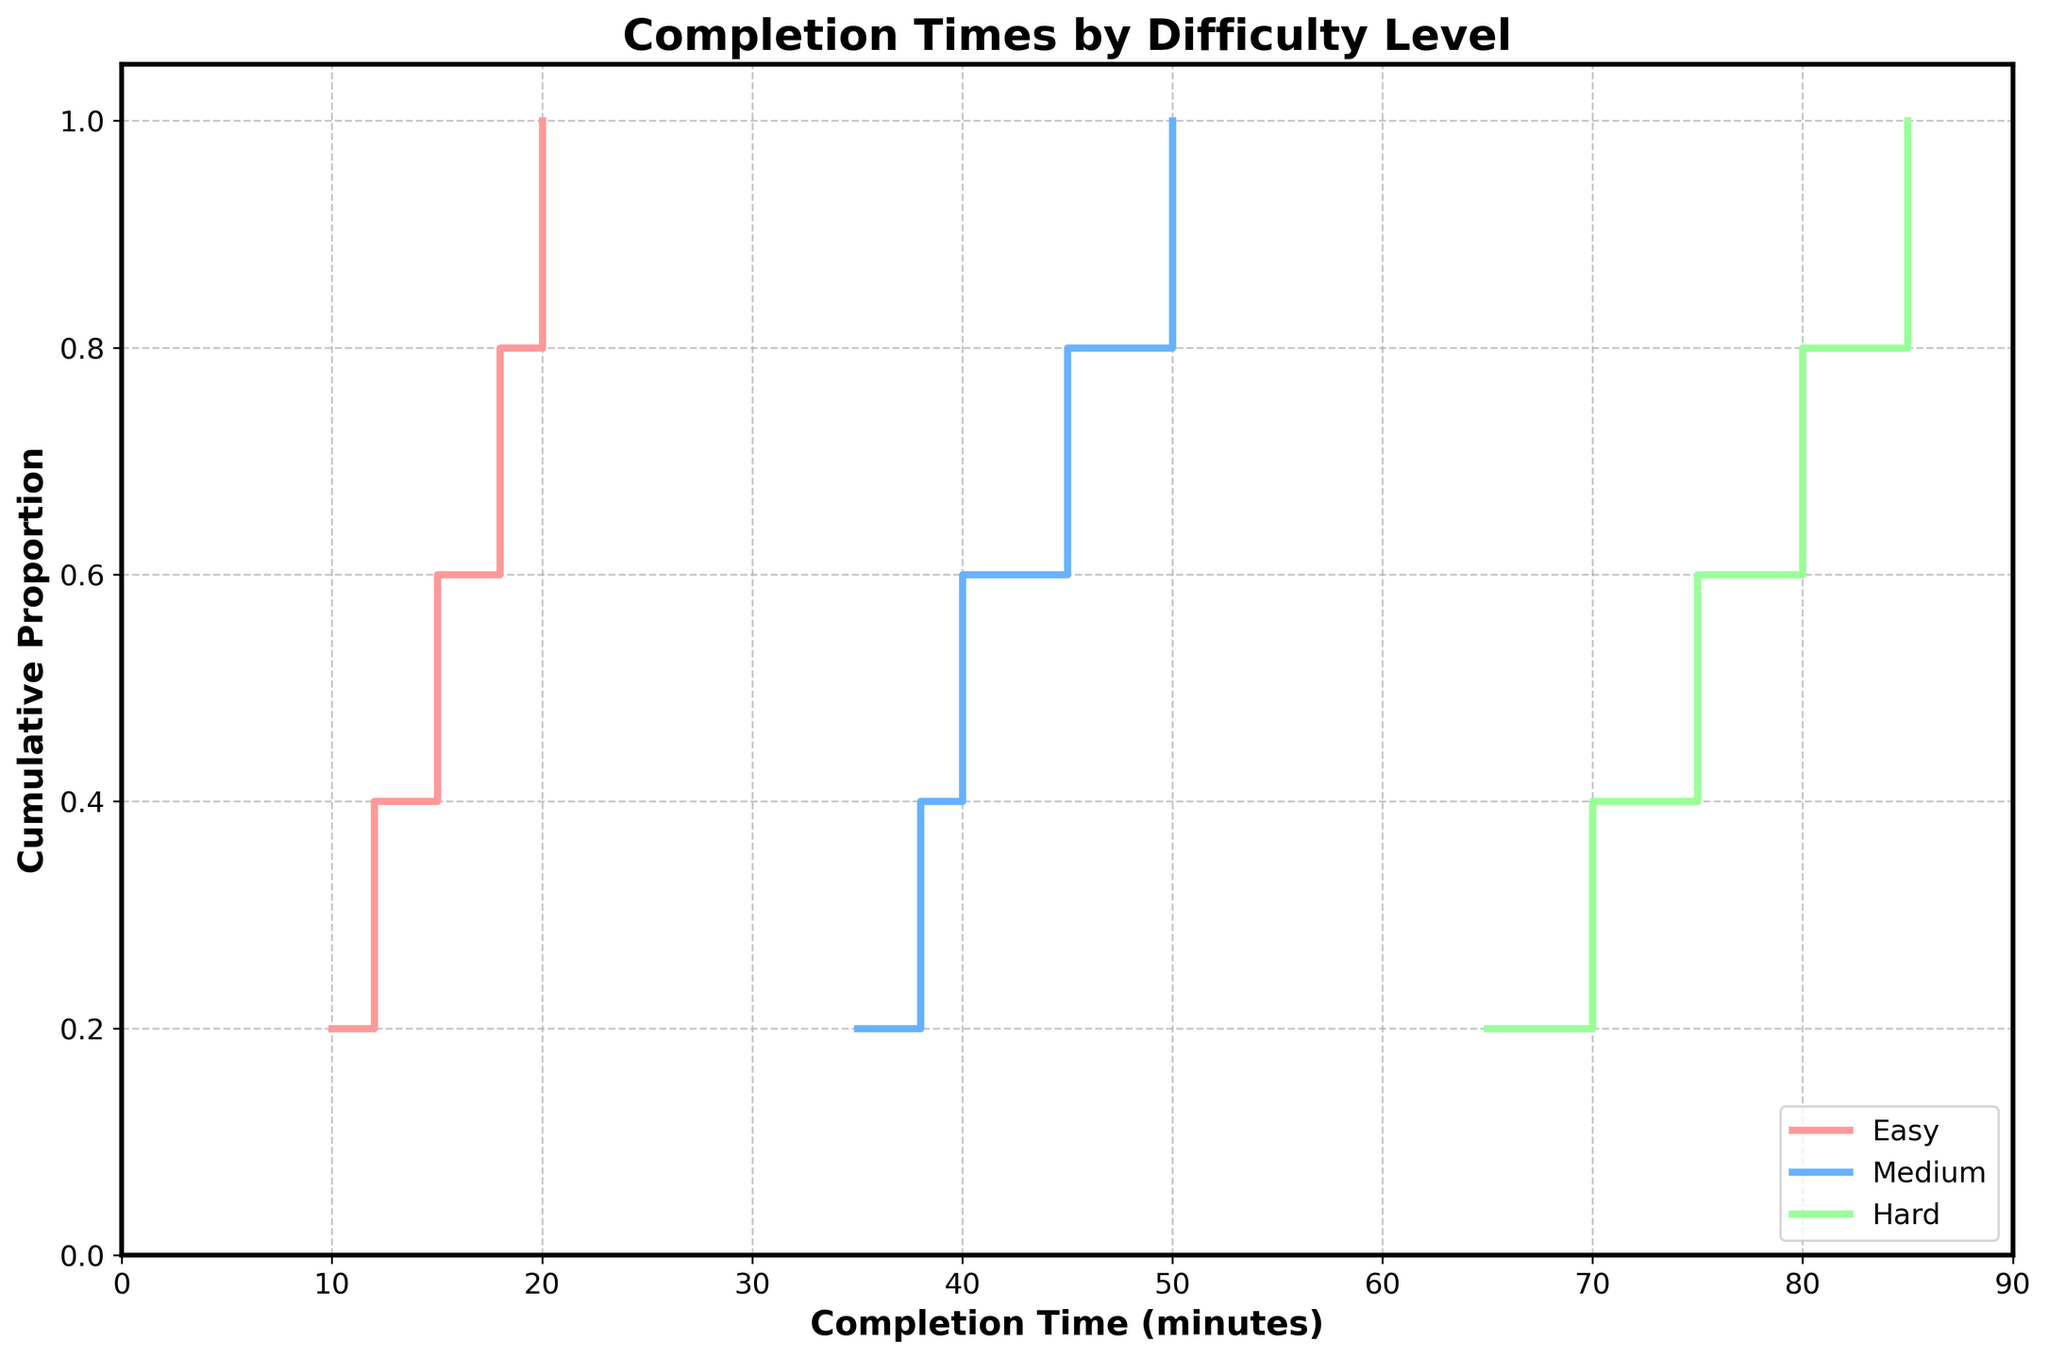What is the title of the plot? The title is displayed at the top of the plot and clearly mentions what the plot is depicting.
Answer: Completion Times by Difficulty Level What is the x-axis labeled as? The x-axis label should be mentioned in the plot, indicating what the x-axis represents.
Answer: Completion Time (minutes) How many difficulty levels are represented in the plot? The plot legend shows the different difficulty levels that are represented in the data.
Answer: 3 (Easy, Medium, Hard) What is the median completion time for the easy difficulty? The median is the middle value of the sorted list. For easy difficulty, sort the completion times and find the middle value. The sorted times are 10, 12, 15, 18, 20. The middle (median) value is 15.
Answer: 15 Which difficulty level shows the fastest completion time? The fastest (minimum) completion time for each difficulty level is at the beginning of each step plot line. Compare these starting points across difficulty levels.
Answer: Easy What is the cumulative proportion of participants who completed the medium difficulty challenge within 45 minutes? For Medium difficulty, find the corresponding y-value where the x-value is 45. The y-value represents the cumulative proportion.
Answer: 0.6 Are the completion times for hard difficulty more varied than for easy difficulty? To determine this, compare the range and spread of completion times in the step plots for hard and easy difficulties. Hard difficulty spans a wider range of completion times compared to easy difficulty.
Answer: Yes What can you infer about the difficulty of the challenges based on the completion times? By observing the step plot, we see that as the difficulty increases, the completion times increase as well. This suggests that harder challenges take more time to complete.
Answer: Harder challenges take more time What is the maximum completion time for the hard difficulty? The maximum completion time can be found at the highest point on the x-axis for the hard difficulty step plot.
Answer: 85 Which difficulty level shows the smallest spread in completion times? Observe the width of the steps for each difficulty level. The smallest spread is indicated by the shortest range on the x-axis.
Answer: Easy 